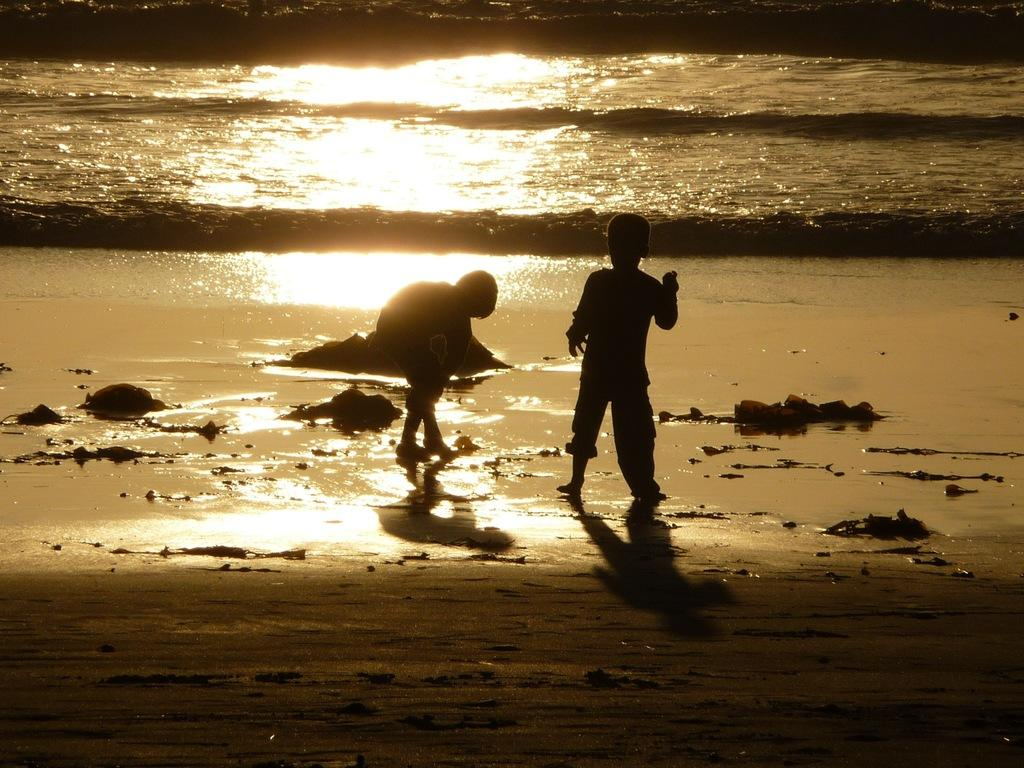How many children are present in the image? There are two children in the image. What can be seen in the background or foreground of the image? There is water visible in the image. What type of apple can be seen floating in the water in the image? There is no apple present in the image; it only features two children and water. 